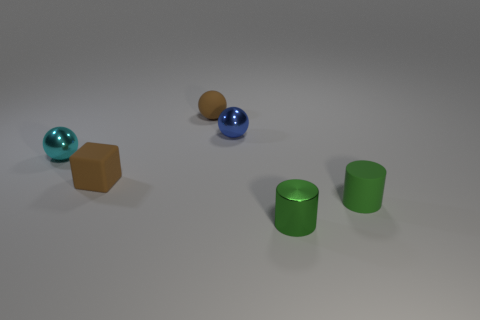Subtract all purple balls. Subtract all purple cubes. How many balls are left? 3 Add 4 red metallic spheres. How many objects exist? 10 Subtract all cubes. How many objects are left? 5 Add 2 large red cylinders. How many large red cylinders exist? 2 Subtract 0 brown cylinders. How many objects are left? 6 Subtract all green cylinders. Subtract all brown spheres. How many objects are left? 3 Add 2 small green metallic cylinders. How many small green metallic cylinders are left? 3 